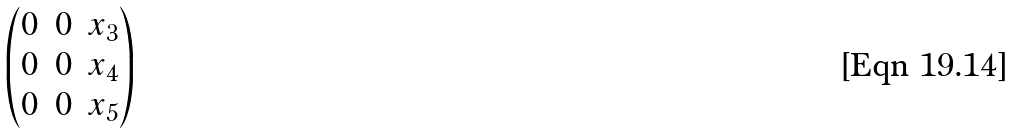<formula> <loc_0><loc_0><loc_500><loc_500>\begin{pmatrix} 0 & 0 & x _ { 3 } \\ 0 & 0 & x _ { 4 } \\ 0 & 0 & x _ { 5 } \end{pmatrix}</formula> 